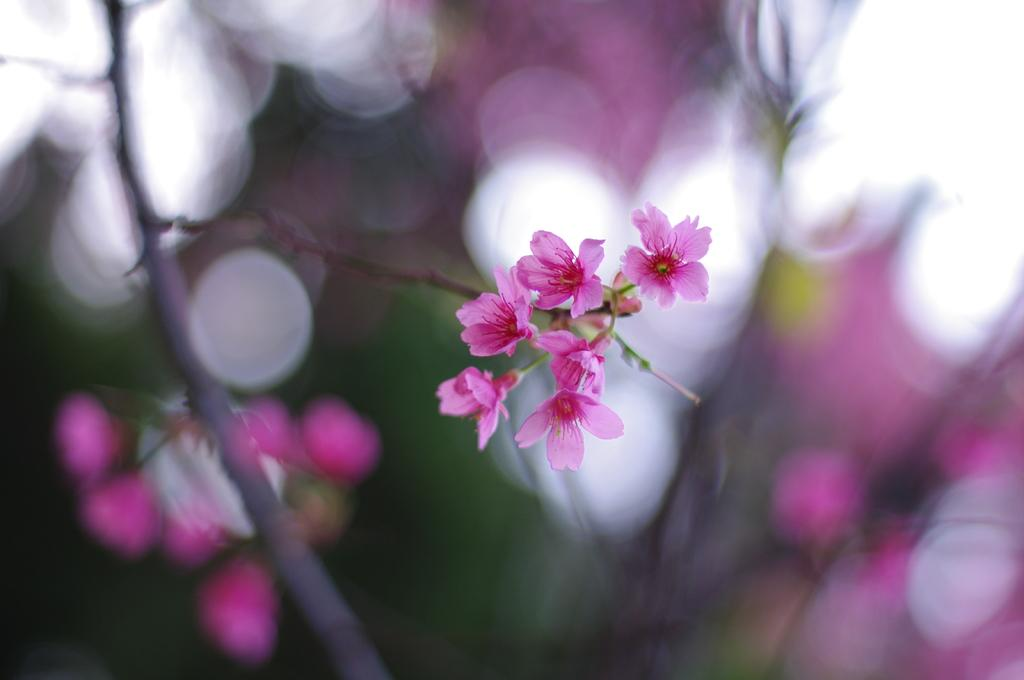What type of flowers are on the plant in the image? There are small pink flowers on a plant in the image. Can you describe the background of the image? The background of the image is blurry. What type of clover is growing next to the grandfather in the image? There is no clover or grandfather present in the image; it only features small pink flowers on a plant and a blurry background. Is the gun visible in the image? There is no gun present in the image. 